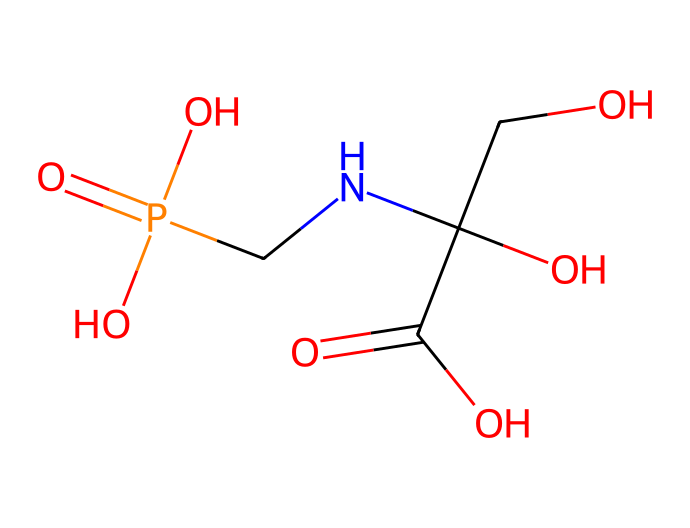What is the molecular formula of glyphosate? To find the molecular formula, we count the number of each type of atom in the SMILES representation. The structure contains: 3 carbon (C) atoms, 10 hydrogen (H) atoms, 1 nitrogen (N) atom, 1 phosphorus (P) atom, and 4 oxygen (O) atoms, leading to the formula C3H10N1P1O4.
Answer: C3H10N1P1O4 How many chiral centers are present in glyphosate? A chiral center is usually a carbon atom bonded to four different groups. In the structure, examine the carbon atoms: the central carbon in the chain has three distinct groups (attached to OH, COO, and a side chain), confirming it as a chiral center. Thus, there is 1 chiral center.
Answer: 1 What type of functional group is present in glyphosate? Looking at the structure, glyphosate contains various functional groups such as amine (due to the nitrogen), carboxylic acids (from the C(=O)O), and phosphonate (containing P=O). Notably, the presence of the carboxylic acid group is significant for its herbicidal activity.
Answer: carboxylic acid How many total atoms are in the glyphosate molecule? To determine the total number of atoms, we add the counts of each atom: 3 carbon (C) + 10 hydrogen (H) + 1 nitrogen (N) + 1 phosphorus (P) + 4 oxygen (O) = 19 total atoms.
Answer: 19 What is the primary use of glyphosate? Glyphosate is primarily used as a herbicide to control broadleaf weeds and grasses in agricultural settings, thus indicating its primary application.
Answer: herbicide What impact does glyphosate have on urban green spaces? Glyphosate can impact urban green spaces by controlling unwanted vegetation but may also pose risks to biodiversity and human health, raising concerns about its environmental effects.
Answer: environmental impact 